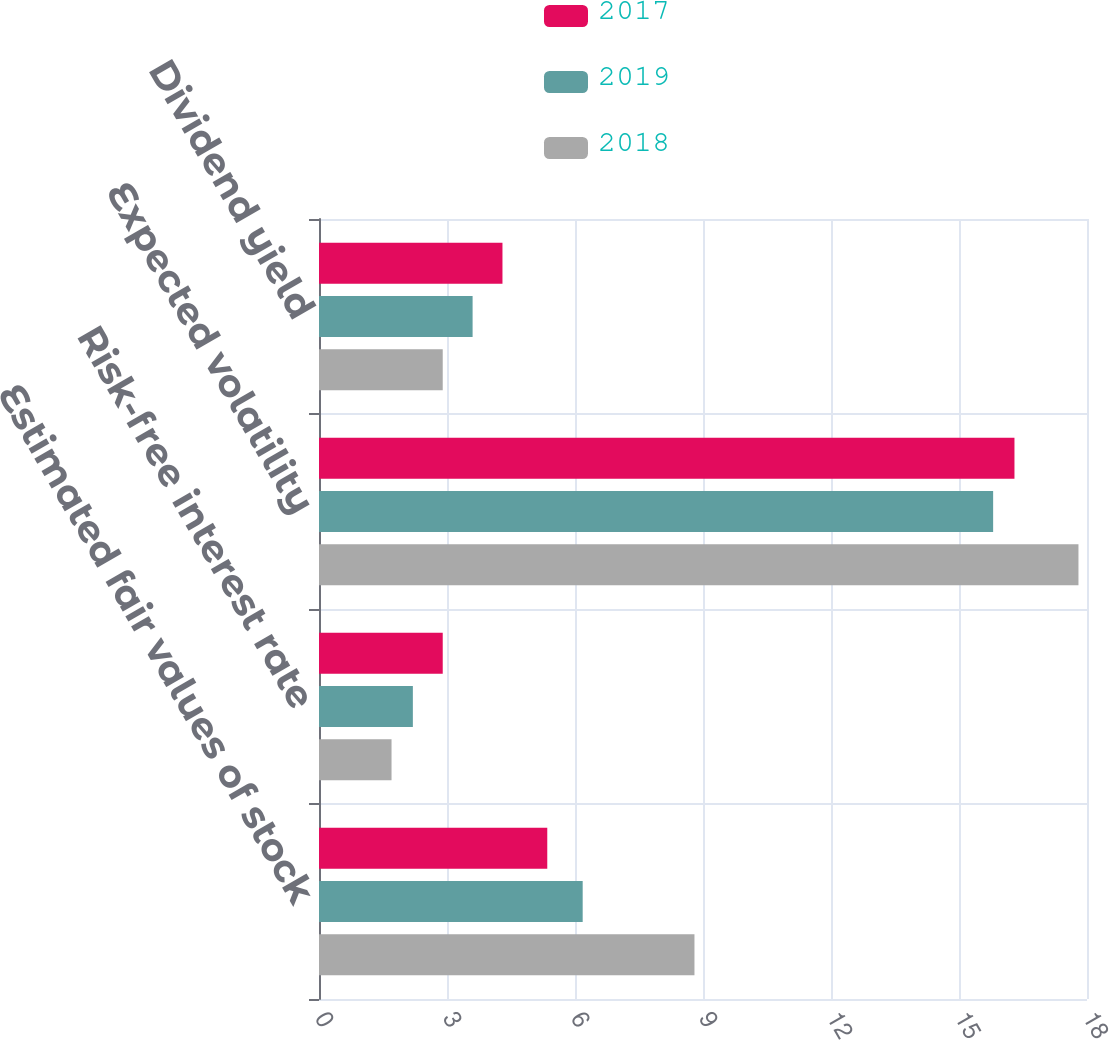Convert chart. <chart><loc_0><loc_0><loc_500><loc_500><stacked_bar_chart><ecel><fcel>Estimated fair values of stock<fcel>Risk-free interest rate<fcel>Expected volatility<fcel>Dividend yield<nl><fcel>2017<fcel>5.35<fcel>2.9<fcel>16.3<fcel>4.3<nl><fcel>2019<fcel>6.18<fcel>2.2<fcel>15.8<fcel>3.6<nl><fcel>2018<fcel>8.8<fcel>1.7<fcel>17.8<fcel>2.9<nl></chart> 